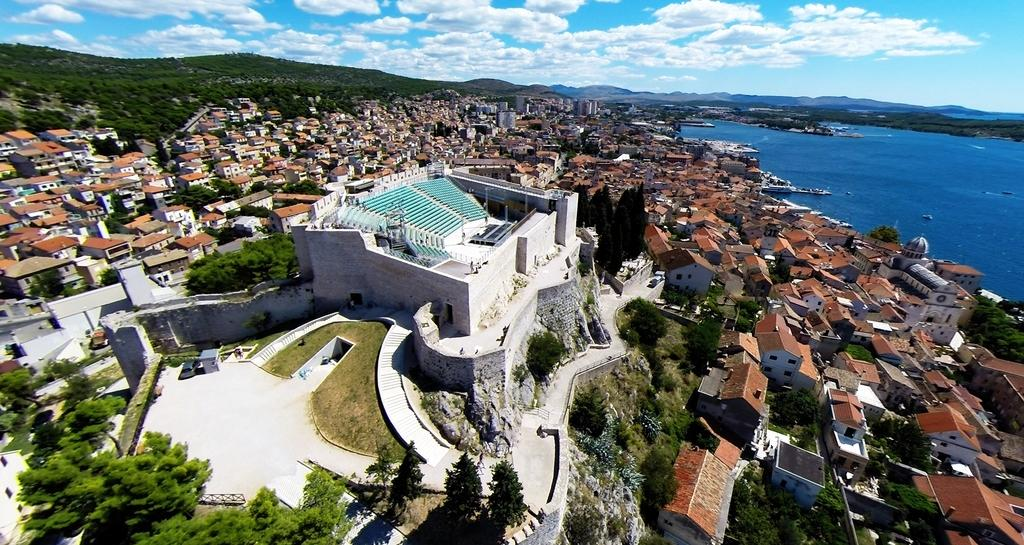What type of landscape is depicted in the image? The image shows a view of a city. What structures can be seen in the city? There are buildings and houses in the image. What natural elements are present in the image? Trees and hills are visible in the image. What body of water is present in the image? There is water on the right side of the image. What part of the natural environment is visible in the background of the image? The sky is visible in the background of the image. What type of suit is being worn by the machine in the image? There is no machine or suit present in the image. 